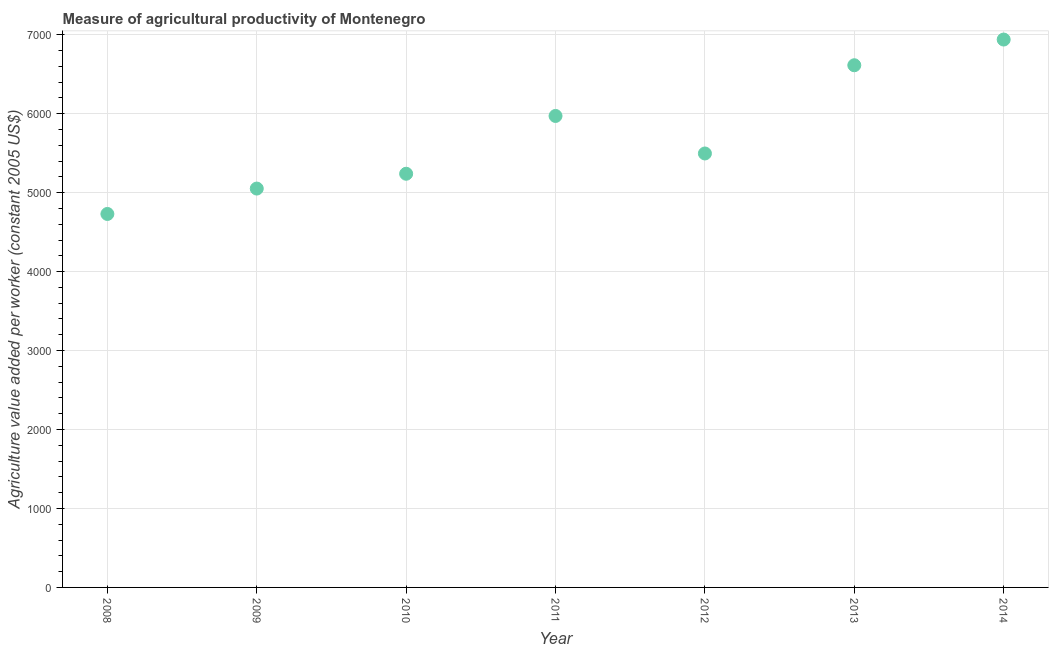What is the agriculture value added per worker in 2008?
Make the answer very short. 4730.12. Across all years, what is the maximum agriculture value added per worker?
Give a very brief answer. 6939.21. Across all years, what is the minimum agriculture value added per worker?
Ensure brevity in your answer.  4730.12. What is the sum of the agriculture value added per worker?
Your answer should be very brief. 4.00e+04. What is the difference between the agriculture value added per worker in 2008 and 2010?
Your response must be concise. -509.3. What is the average agriculture value added per worker per year?
Give a very brief answer. 5720.27. What is the median agriculture value added per worker?
Your answer should be very brief. 5496.22. In how many years, is the agriculture value added per worker greater than 3800 US$?
Offer a terse response. 7. Do a majority of the years between 2008 and 2014 (inclusive) have agriculture value added per worker greater than 6800 US$?
Make the answer very short. No. What is the ratio of the agriculture value added per worker in 2010 to that in 2011?
Give a very brief answer. 0.88. Is the agriculture value added per worker in 2009 less than that in 2010?
Ensure brevity in your answer.  Yes. Is the difference between the agriculture value added per worker in 2009 and 2011 greater than the difference between any two years?
Your answer should be very brief. No. What is the difference between the highest and the second highest agriculture value added per worker?
Offer a very short reply. 325.54. What is the difference between the highest and the lowest agriculture value added per worker?
Ensure brevity in your answer.  2209.09. In how many years, is the agriculture value added per worker greater than the average agriculture value added per worker taken over all years?
Give a very brief answer. 3. Does the agriculture value added per worker monotonically increase over the years?
Your response must be concise. No. How many years are there in the graph?
Give a very brief answer. 7. What is the title of the graph?
Make the answer very short. Measure of agricultural productivity of Montenegro. What is the label or title of the X-axis?
Provide a succinct answer. Year. What is the label or title of the Y-axis?
Your response must be concise. Agriculture value added per worker (constant 2005 US$). What is the Agriculture value added per worker (constant 2005 US$) in 2008?
Your answer should be very brief. 4730.12. What is the Agriculture value added per worker (constant 2005 US$) in 2009?
Provide a short and direct response. 5051.79. What is the Agriculture value added per worker (constant 2005 US$) in 2010?
Offer a very short reply. 5239.42. What is the Agriculture value added per worker (constant 2005 US$) in 2011?
Give a very brief answer. 5971.47. What is the Agriculture value added per worker (constant 2005 US$) in 2012?
Provide a succinct answer. 5496.22. What is the Agriculture value added per worker (constant 2005 US$) in 2013?
Keep it short and to the point. 6613.67. What is the Agriculture value added per worker (constant 2005 US$) in 2014?
Your response must be concise. 6939.21. What is the difference between the Agriculture value added per worker (constant 2005 US$) in 2008 and 2009?
Offer a terse response. -321.67. What is the difference between the Agriculture value added per worker (constant 2005 US$) in 2008 and 2010?
Make the answer very short. -509.3. What is the difference between the Agriculture value added per worker (constant 2005 US$) in 2008 and 2011?
Provide a succinct answer. -1241.34. What is the difference between the Agriculture value added per worker (constant 2005 US$) in 2008 and 2012?
Offer a terse response. -766.09. What is the difference between the Agriculture value added per worker (constant 2005 US$) in 2008 and 2013?
Keep it short and to the point. -1883.55. What is the difference between the Agriculture value added per worker (constant 2005 US$) in 2008 and 2014?
Offer a very short reply. -2209.09. What is the difference between the Agriculture value added per worker (constant 2005 US$) in 2009 and 2010?
Your response must be concise. -187.63. What is the difference between the Agriculture value added per worker (constant 2005 US$) in 2009 and 2011?
Provide a short and direct response. -919.67. What is the difference between the Agriculture value added per worker (constant 2005 US$) in 2009 and 2012?
Your answer should be very brief. -444.42. What is the difference between the Agriculture value added per worker (constant 2005 US$) in 2009 and 2013?
Provide a short and direct response. -1561.88. What is the difference between the Agriculture value added per worker (constant 2005 US$) in 2009 and 2014?
Your answer should be compact. -1887.42. What is the difference between the Agriculture value added per worker (constant 2005 US$) in 2010 and 2011?
Provide a short and direct response. -732.05. What is the difference between the Agriculture value added per worker (constant 2005 US$) in 2010 and 2012?
Ensure brevity in your answer.  -256.8. What is the difference between the Agriculture value added per worker (constant 2005 US$) in 2010 and 2013?
Ensure brevity in your answer.  -1374.25. What is the difference between the Agriculture value added per worker (constant 2005 US$) in 2010 and 2014?
Give a very brief answer. -1699.79. What is the difference between the Agriculture value added per worker (constant 2005 US$) in 2011 and 2012?
Offer a terse response. 475.25. What is the difference between the Agriculture value added per worker (constant 2005 US$) in 2011 and 2013?
Keep it short and to the point. -642.2. What is the difference between the Agriculture value added per worker (constant 2005 US$) in 2011 and 2014?
Provide a short and direct response. -967.75. What is the difference between the Agriculture value added per worker (constant 2005 US$) in 2012 and 2013?
Your answer should be very brief. -1117.45. What is the difference between the Agriculture value added per worker (constant 2005 US$) in 2012 and 2014?
Provide a short and direct response. -1443. What is the difference between the Agriculture value added per worker (constant 2005 US$) in 2013 and 2014?
Your response must be concise. -325.54. What is the ratio of the Agriculture value added per worker (constant 2005 US$) in 2008 to that in 2009?
Offer a very short reply. 0.94. What is the ratio of the Agriculture value added per worker (constant 2005 US$) in 2008 to that in 2010?
Provide a succinct answer. 0.9. What is the ratio of the Agriculture value added per worker (constant 2005 US$) in 2008 to that in 2011?
Your response must be concise. 0.79. What is the ratio of the Agriculture value added per worker (constant 2005 US$) in 2008 to that in 2012?
Provide a succinct answer. 0.86. What is the ratio of the Agriculture value added per worker (constant 2005 US$) in 2008 to that in 2013?
Give a very brief answer. 0.71. What is the ratio of the Agriculture value added per worker (constant 2005 US$) in 2008 to that in 2014?
Your answer should be compact. 0.68. What is the ratio of the Agriculture value added per worker (constant 2005 US$) in 2009 to that in 2010?
Keep it short and to the point. 0.96. What is the ratio of the Agriculture value added per worker (constant 2005 US$) in 2009 to that in 2011?
Keep it short and to the point. 0.85. What is the ratio of the Agriculture value added per worker (constant 2005 US$) in 2009 to that in 2012?
Offer a terse response. 0.92. What is the ratio of the Agriculture value added per worker (constant 2005 US$) in 2009 to that in 2013?
Your answer should be compact. 0.76. What is the ratio of the Agriculture value added per worker (constant 2005 US$) in 2009 to that in 2014?
Make the answer very short. 0.73. What is the ratio of the Agriculture value added per worker (constant 2005 US$) in 2010 to that in 2011?
Your answer should be compact. 0.88. What is the ratio of the Agriculture value added per worker (constant 2005 US$) in 2010 to that in 2012?
Your answer should be very brief. 0.95. What is the ratio of the Agriculture value added per worker (constant 2005 US$) in 2010 to that in 2013?
Provide a succinct answer. 0.79. What is the ratio of the Agriculture value added per worker (constant 2005 US$) in 2010 to that in 2014?
Make the answer very short. 0.76. What is the ratio of the Agriculture value added per worker (constant 2005 US$) in 2011 to that in 2012?
Make the answer very short. 1.09. What is the ratio of the Agriculture value added per worker (constant 2005 US$) in 2011 to that in 2013?
Offer a very short reply. 0.9. What is the ratio of the Agriculture value added per worker (constant 2005 US$) in 2011 to that in 2014?
Provide a short and direct response. 0.86. What is the ratio of the Agriculture value added per worker (constant 2005 US$) in 2012 to that in 2013?
Your answer should be very brief. 0.83. What is the ratio of the Agriculture value added per worker (constant 2005 US$) in 2012 to that in 2014?
Make the answer very short. 0.79. What is the ratio of the Agriculture value added per worker (constant 2005 US$) in 2013 to that in 2014?
Ensure brevity in your answer.  0.95. 